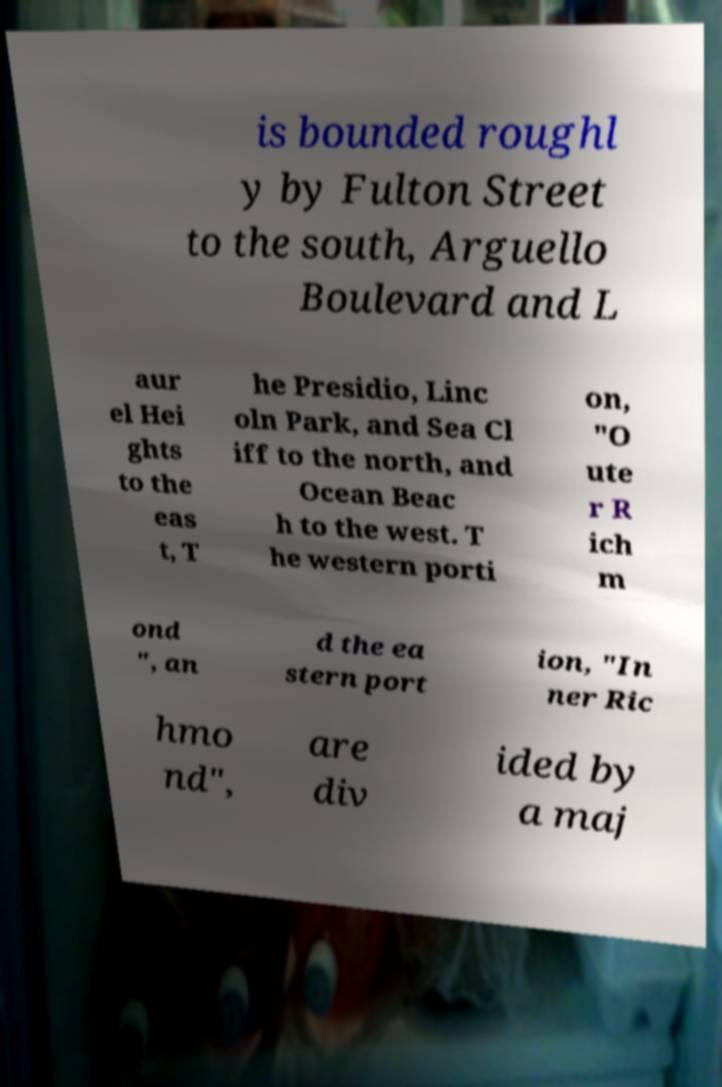Please read and relay the text visible in this image. What does it say? is bounded roughl y by Fulton Street to the south, Arguello Boulevard and L aur el Hei ghts to the eas t, T he Presidio, Linc oln Park, and Sea Cl iff to the north, and Ocean Beac h to the west. T he western porti on, "O ute r R ich m ond ", an d the ea stern port ion, "In ner Ric hmo nd", are div ided by a maj 